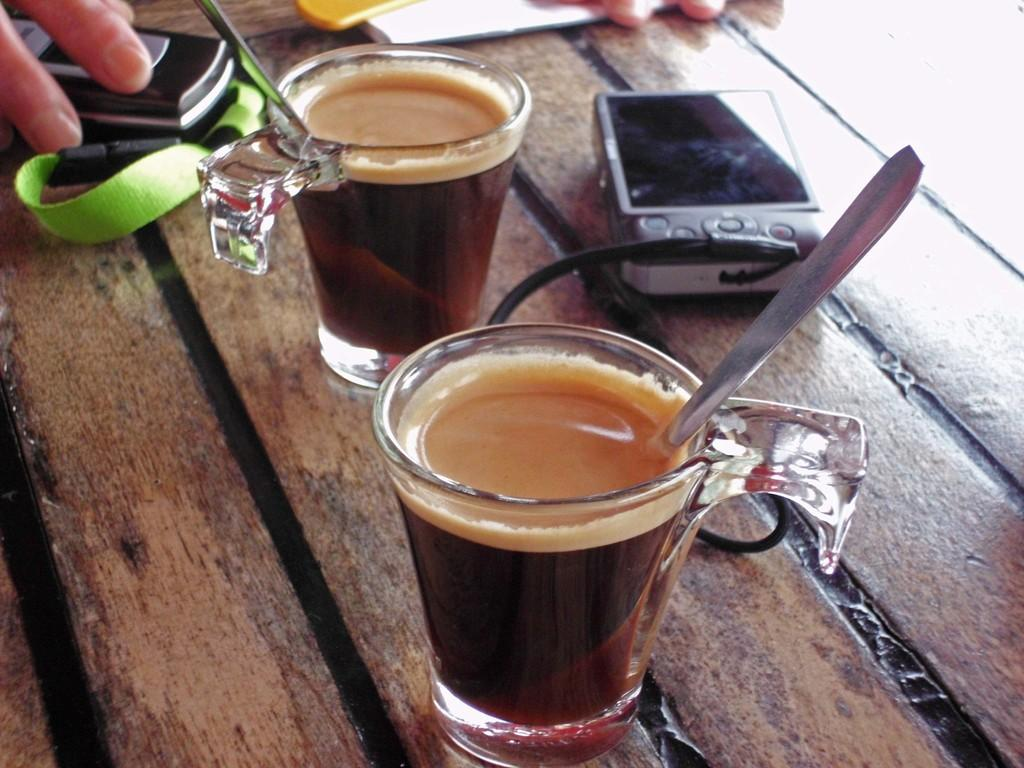What objects are present in the image that are related to serving or consuming tea? There are tea glasses with spoons in the image. What electronic device can be seen in the image? There is a mobile phone in the image. What device is used for capturing images in the image? There is a camera in the image. Where are these objects located in the image? The objects are on a table. Whose hands are visible in the image? Some persons' hands are visible in the image. What type of oil is being used to lubricate the camera in the image? There is no oil present in the image, and the camera does not require lubrication. 